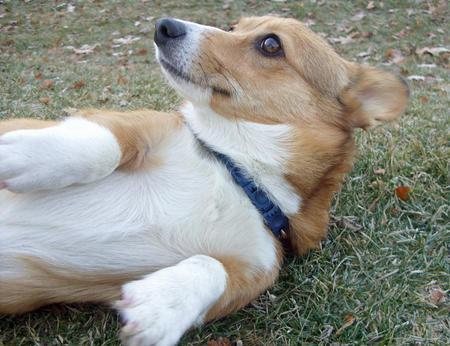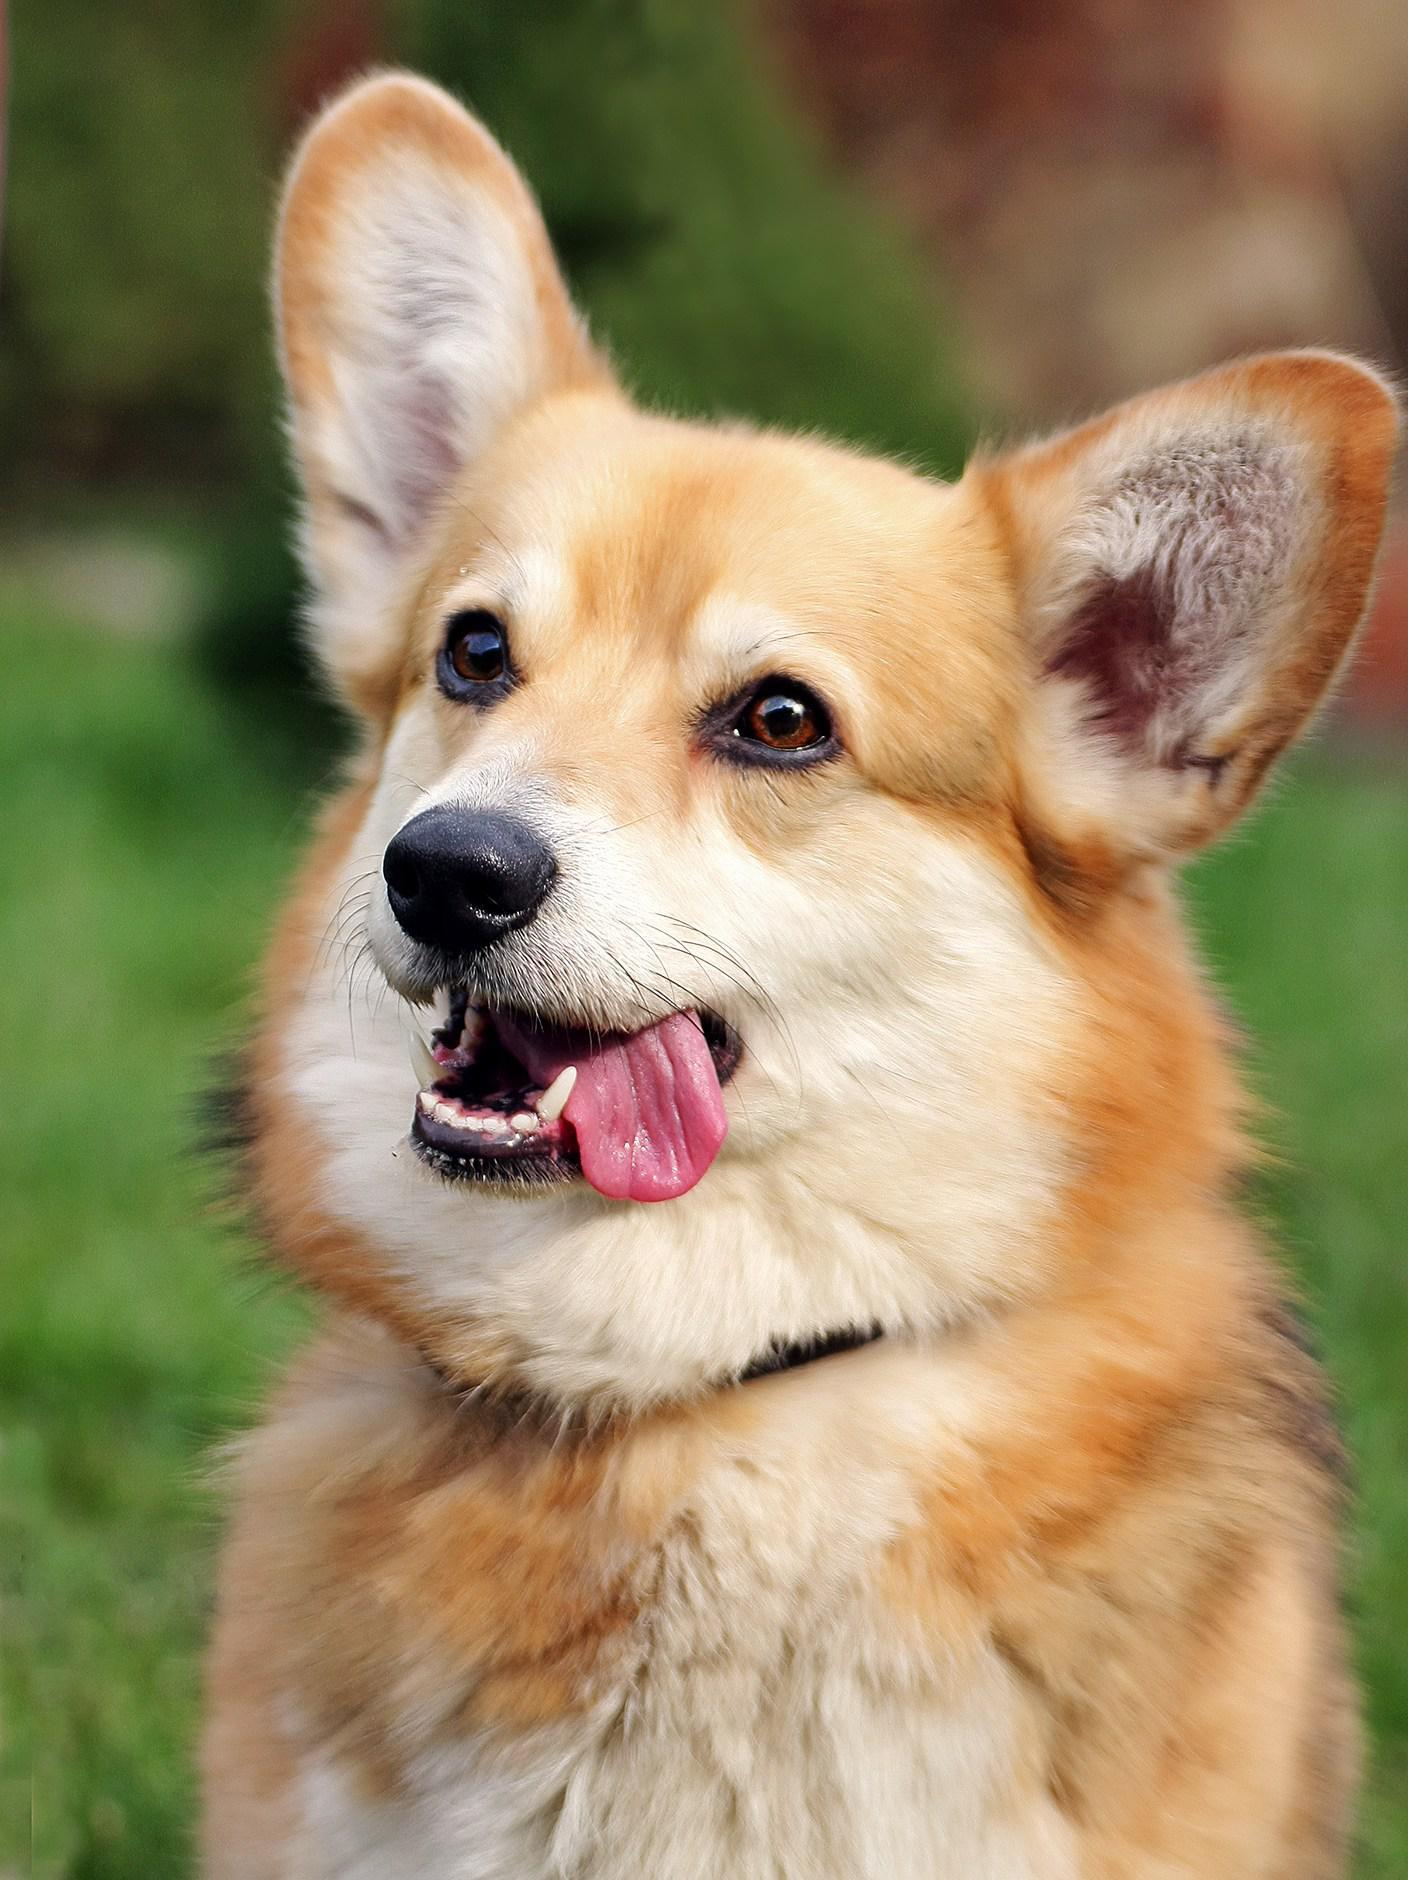The first image is the image on the left, the second image is the image on the right. Given the left and right images, does the statement "The dog in the image on the right is standing on all fours in the grass." hold true? Answer yes or no. No. The first image is the image on the left, the second image is the image on the right. For the images displayed, is the sentence "An image shows one dog with upright ears posed with white flowers." factually correct? Answer yes or no. No. 